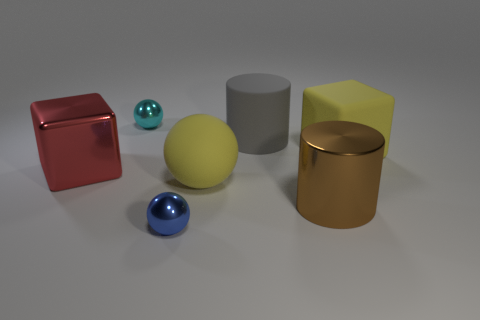The object that is the same color as the large ball is what shape?
Your answer should be compact. Cube. There is a matte object that is the same color as the rubber cube; what size is it?
Ensure brevity in your answer.  Large. What color is the big sphere?
Provide a short and direct response. Yellow. The sphere that is in front of the yellow matte object that is in front of the large block on the left side of the cyan thing is what color?
Offer a terse response. Blue. Does the tiny cyan ball have the same material as the big brown cylinder?
Offer a terse response. Yes. How many blue things are big blocks or shiny things?
Your response must be concise. 1. There is a large gray rubber cylinder; how many cylinders are right of it?
Your answer should be compact. 1. Are there more big objects than red metallic cubes?
Provide a succinct answer. Yes. There is a large shiny thing that is to the right of the tiny shiny sphere that is left of the blue ball; what is its shape?
Give a very brief answer. Cylinder. Does the large rubber sphere have the same color as the rubber cube?
Give a very brief answer. Yes. 